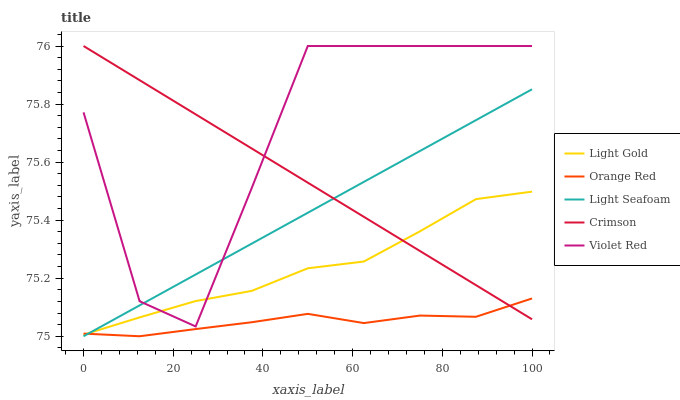Does Light Seafoam have the minimum area under the curve?
Answer yes or no. No. Does Light Seafoam have the maximum area under the curve?
Answer yes or no. No. Is Violet Red the smoothest?
Answer yes or no. No. Is Light Seafoam the roughest?
Answer yes or no. No. Does Violet Red have the lowest value?
Answer yes or no. No. Does Light Seafoam have the highest value?
Answer yes or no. No. Is Orange Red less than Violet Red?
Answer yes or no. Yes. Is Violet Red greater than Orange Red?
Answer yes or no. Yes. Does Orange Red intersect Violet Red?
Answer yes or no. No. 